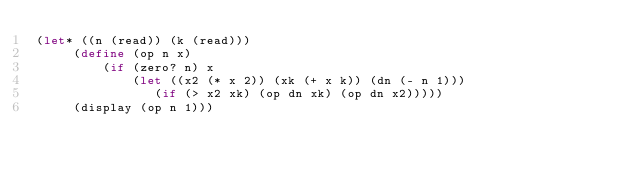<code> <loc_0><loc_0><loc_500><loc_500><_Scheme_>(let* ((n (read)) (k (read)))
     (define (op n x)
         (if (zero? n) x
             (let ((x2 (* x 2)) (xk (+ x k)) (dn (- n 1)))
                (if (> x2 xk) (op dn xk) (op dn x2)))))
     (display (op n 1)))</code> 